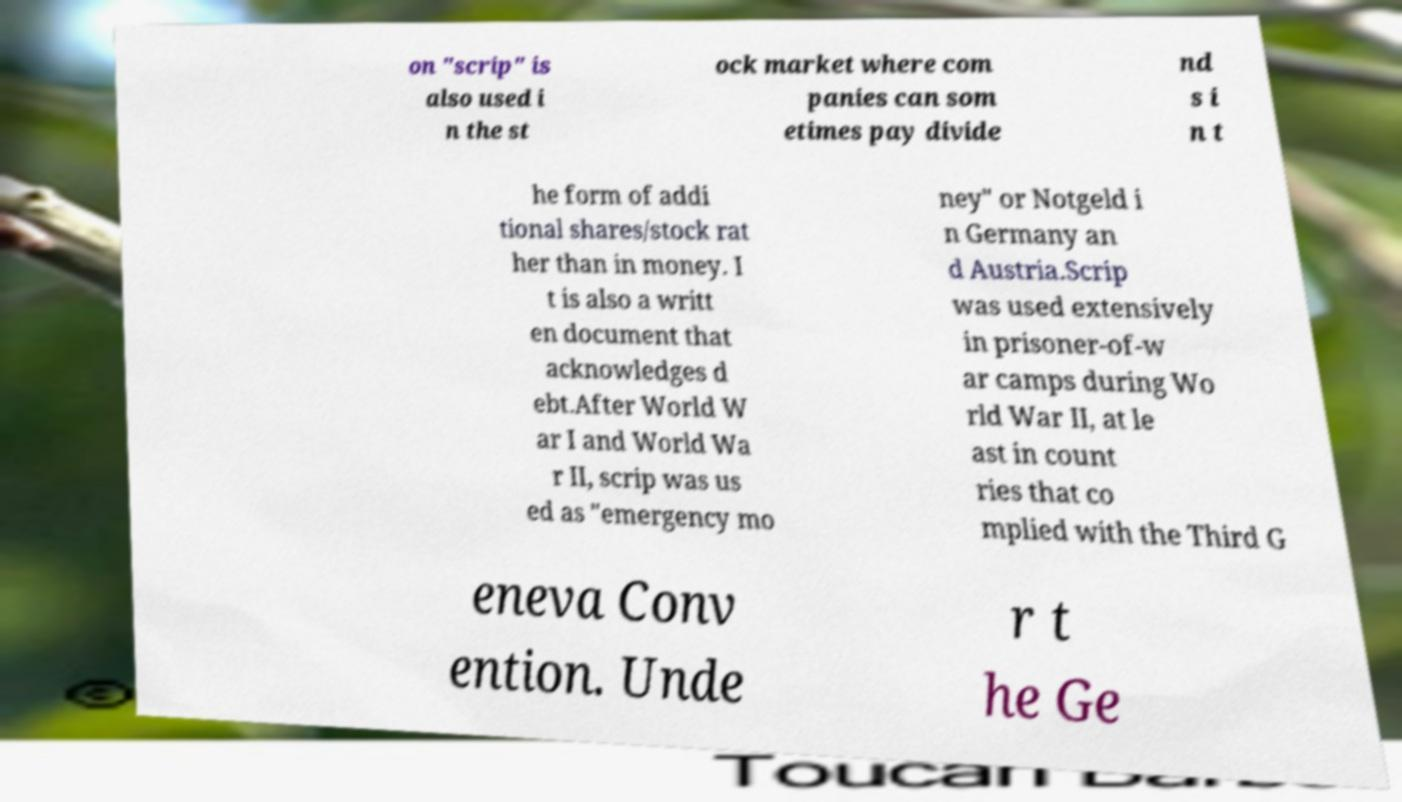Could you extract and type out the text from this image? on "scrip" is also used i n the st ock market where com panies can som etimes pay divide nd s i n t he form of addi tional shares/stock rat her than in money. I t is also a writt en document that acknowledges d ebt.After World W ar I and World Wa r II, scrip was us ed as "emergency mo ney" or Notgeld i n Germany an d Austria.Scrip was used extensively in prisoner-of-w ar camps during Wo rld War II, at le ast in count ries that co mplied with the Third G eneva Conv ention. Unde r t he Ge 